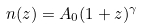Convert formula to latex. <formula><loc_0><loc_0><loc_500><loc_500>n ( z ) = A _ { 0 } ( 1 + z ) ^ { \gamma }</formula> 